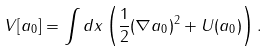Convert formula to latex. <formula><loc_0><loc_0><loc_500><loc_500>V [ a _ { 0 } ] = \int d x \left ( \frac { 1 } { 2 } ( \nabla a _ { 0 } ) ^ { 2 } + U ( a _ { 0 } ) \right ) .</formula> 